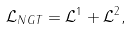Convert formula to latex. <formula><loc_0><loc_0><loc_500><loc_500>\mathcal { L } _ { N G T } = \mathcal { L } ^ { 1 } + \mathcal { L } ^ { 2 } ,</formula> 